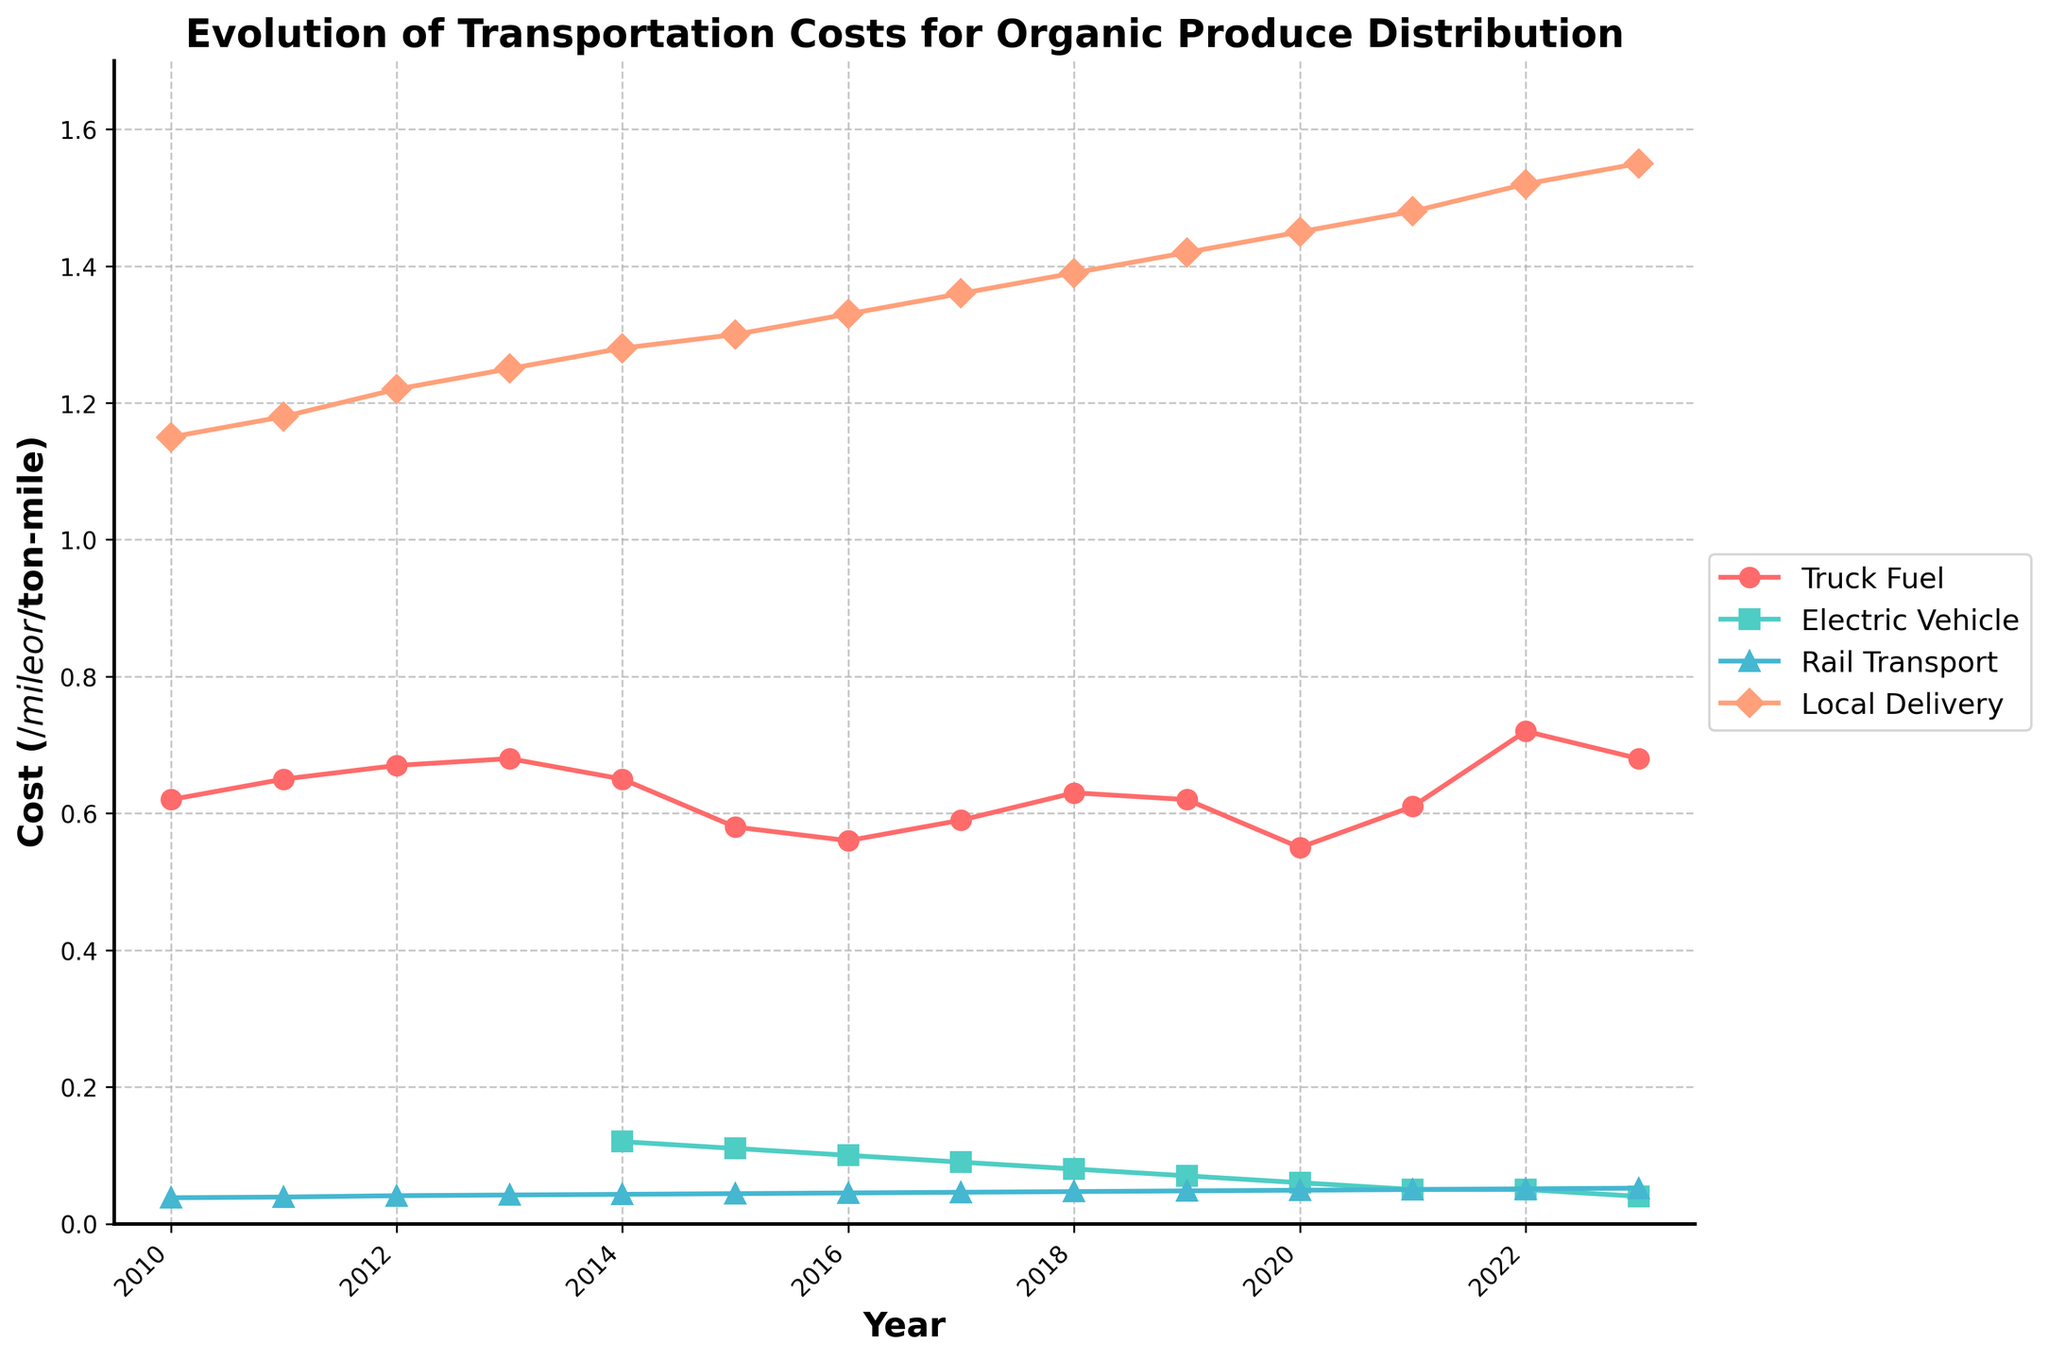What year did Electric Vehicle Costs start being recorded and how did this year compare in Truck Fuel Cost to the previous year? Electric Vehicle Costs started being recorded in 2014. In 2014, the Truck Fuel Cost was 0.65 $/mile which is a decrease from 0.68 $/mile in 2013.
Answer: 2014, decrease In which year did Truck Fuel Cost experience the highest value and what was the value? To determine the highest value, we scan the Truck Fuel Cost series and identify the peak. The highest value occurred in 2022 at 0.72 $/mile.
Answer: 2022, 0.72 $/mile How did Local Delivery Costs evolve from 2010 to 2023? By examining the Local Delivery Cost series, it is evident that Local Delivery Costs steadily increased each year starting from 1.15 $/mile in 2010 to 1.55 $/mile in 2023.
Answer: Steadily increased Comparing Truck Fuel Cost and Electric Vehicle Cost in 2023, which was lower? In 2023, the Truck Fuel Cost was 0.68 $/mile and the Electric Vehicle Cost was 0.04 $/mile. Therefore, the Electric Vehicle Cost was lower.
Answer: Electric Vehicle Cost Between 2015 and 2016, how did the Rail Transport Cost change? The Rail Transport Cost increased from 0.044 $/ton-mile in 2015 to 0.045 $/ton-mile in 2016.
Answer: Increased What is the average cost of Rail Transport over the years 2010-2023? To find the average, sum up the Rail Transport Costs and then divide by the number of years: (0.038 + 0.039 + 0.041 + 0.042 + 0.043 + 0.044 + 0.045 + 0.046 + 0.047 + 0.048 + 0.049 + 0.050 + 0.051 + 0.052) / 14 = 0.04588 $/ton-mile.
Answer: 0.04588 $/ton-mile By what factor did Electric Vehicle Costs change from 2014 to 2023? The Electric Vehicle Cost in 2014 was 0.12 $/mile and in 2023 it was 0.04 $/mile. The change factor = 0.04 / 0.12 = 1/3.
Answer: 1/3 Which transport method had the highest cost in 2020 and what was the cost? In 2020, Local Delivery Cost was the highest at 1.45 $/mile.
Answer: Local Delivery, 1.45 $/mile 